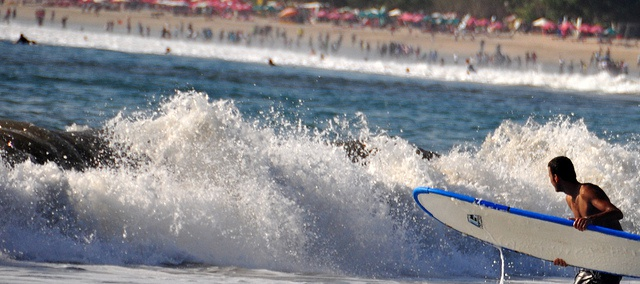Describe the objects in this image and their specific colors. I can see surfboard in gray, darkgray, and navy tones, umbrella in gray, brown, darkgray, and black tones, people in gray, black, maroon, and brown tones, umbrella in gray, brown, lightgray, darkgray, and lightpink tones, and umbrella in gray, brown, lightpink, and tan tones in this image. 